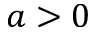Convert formula to latex. <formula><loc_0><loc_0><loc_500><loc_500>a > 0</formula> 